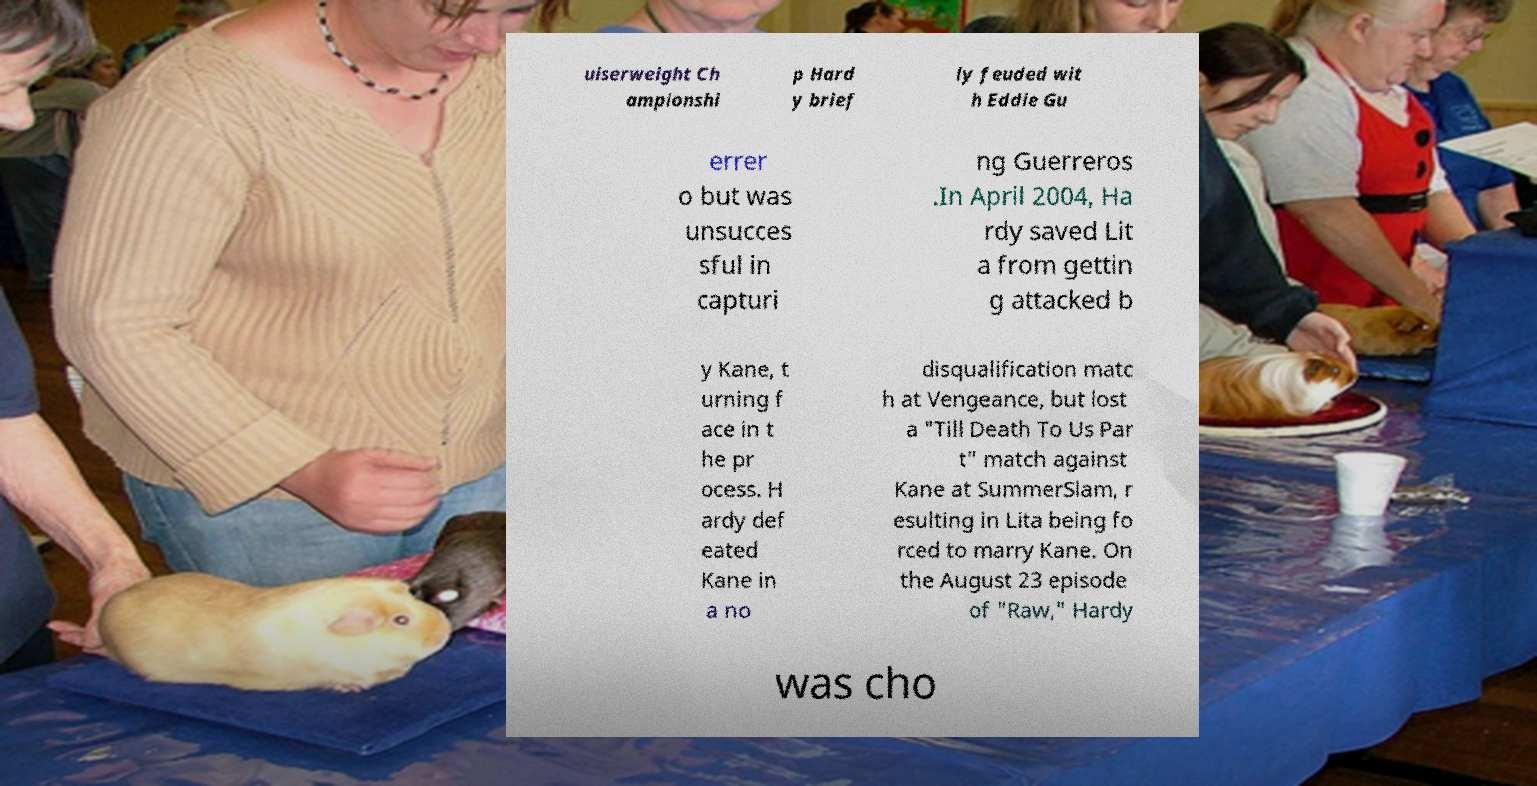There's text embedded in this image that I need extracted. Can you transcribe it verbatim? uiserweight Ch ampionshi p Hard y brief ly feuded wit h Eddie Gu errer o but was unsucces sful in capturi ng Guerreros .In April 2004, Ha rdy saved Lit a from gettin g attacked b y Kane, t urning f ace in t he pr ocess. H ardy def eated Kane in a no disqualification matc h at Vengeance, but lost a "Till Death To Us Par t" match against Kane at SummerSlam, r esulting in Lita being fo rced to marry Kane. On the August 23 episode of "Raw," Hardy was cho 